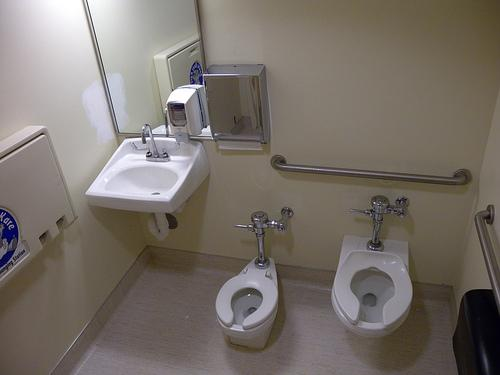Describe the positioning and appearance of the diaper changing table in relation to the other objects in the bathroom. A koala care baby changing station is mounted on the wall near the two white porcelain toilets and features a blue and white decal. Describe any safety features provided for handicapped individuals within this bathroom. There are metal grab bars installed on the walls behind and above the toilets to provide support and safety for handicapped individuals. What type of facility is depicted in the image, and how many toilets does it contain? A family bathroom containing two white porcelain toilets, one standard size and one smaller kid's size. What special feature in the bathroom is meant to accommodate a small child, and where is this feature located? A small white plastic toilet seat is designed for kids, found beside the regular-sized toilet in the restroom. What surface materials are used for the wall and floor of the restroom depicted in the image? The walls have a beige-colored primer and tan-colored paint, while the floor is covered with white tiles. Which two items are directly adjacent to each other above and below the sink, and what is their purpose? A white plastic soap dispenser and a chrome metal sink fixture are adjacent above and below the sink, for dispensing soap and regulating water flow, respectively. Can you provide a brief overview of some prominent features in this restroom image? There is a family restroom with two toilets, a sink, a mirror, a paper towel dispenser, a soap dispenser, a diaper changing table, and grab bars on the walls for safety. Count the combined total number of toilets, sinks, mirrors, and paper towel dispensers in the image. There are a total of 9 items: 2 toilets, 1 sink, 2 mirrors, and 4 paper towel dispensers. What objects are directly above the sink and below the mirror in the image? A white plastic soap dispenser and a chrome metal sink fixture are directly above the sink and below the mirror. How many fixtures are there on the sink, and what color are they? There are two silver fixtures on the sink, one for adjusting water flow and the other for dispensing soap. Can you find the picture of a cat hanging on one of the bathroom walls? It has a frame with dimensions Width:40 Height:40 and is located at X:385 Y:95. No, it's not mentioned in the image. 